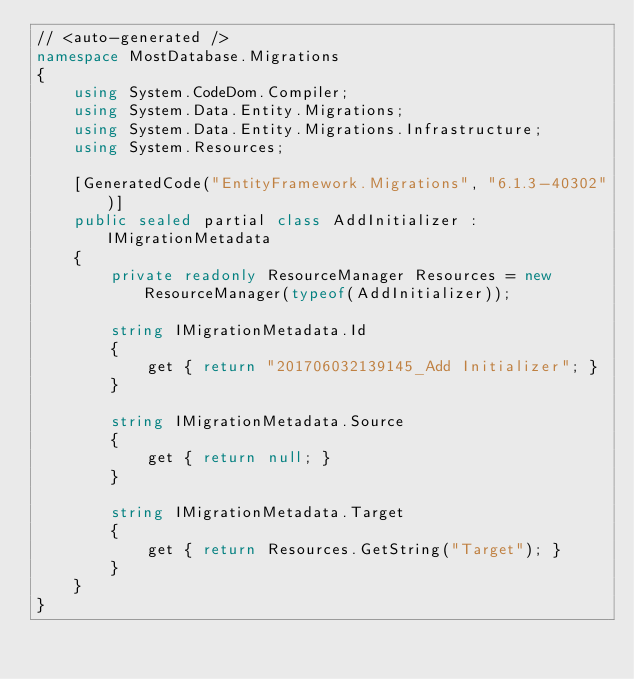Convert code to text. <code><loc_0><loc_0><loc_500><loc_500><_C#_>// <auto-generated />
namespace MostDatabase.Migrations
{
    using System.CodeDom.Compiler;
    using System.Data.Entity.Migrations;
    using System.Data.Entity.Migrations.Infrastructure;
    using System.Resources;
    
    [GeneratedCode("EntityFramework.Migrations", "6.1.3-40302")]
    public sealed partial class AddInitializer : IMigrationMetadata
    {
        private readonly ResourceManager Resources = new ResourceManager(typeof(AddInitializer));
        
        string IMigrationMetadata.Id
        {
            get { return "201706032139145_Add Initializer"; }
        }
        
        string IMigrationMetadata.Source
        {
            get { return null; }
        }
        
        string IMigrationMetadata.Target
        {
            get { return Resources.GetString("Target"); }
        }
    }
}
</code> 